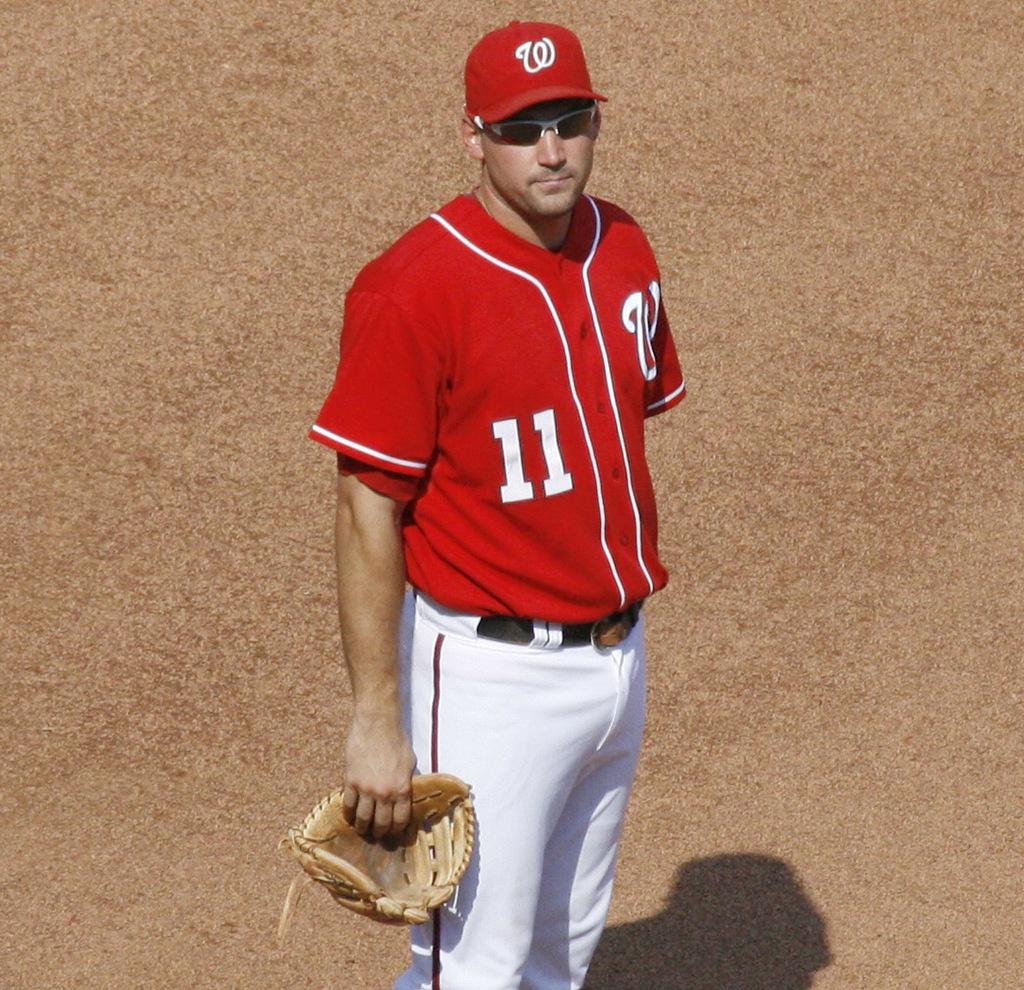What number is on the guys jersey?
Your answer should be very brief. 11. What number is on this player's jersey?
Provide a succinct answer. 11. 